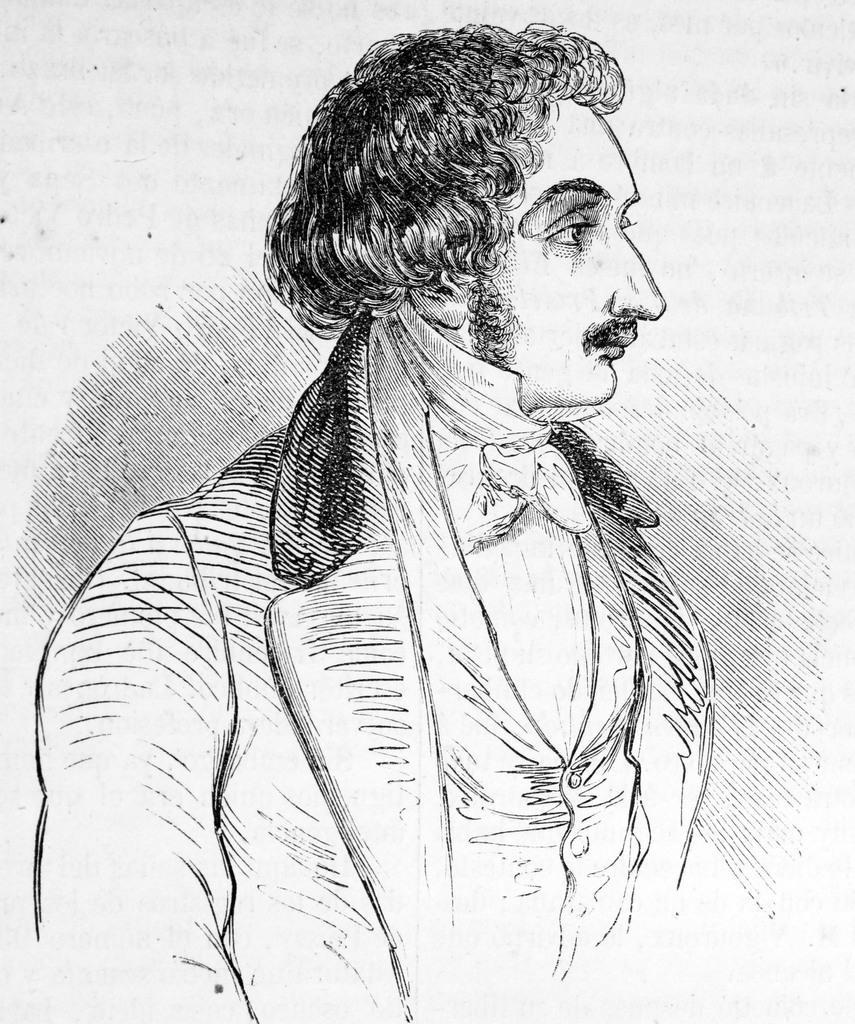Can you describe this image briefly? In this picture we can see the sketch of a man with a mustache. The background of the image is white in color. 